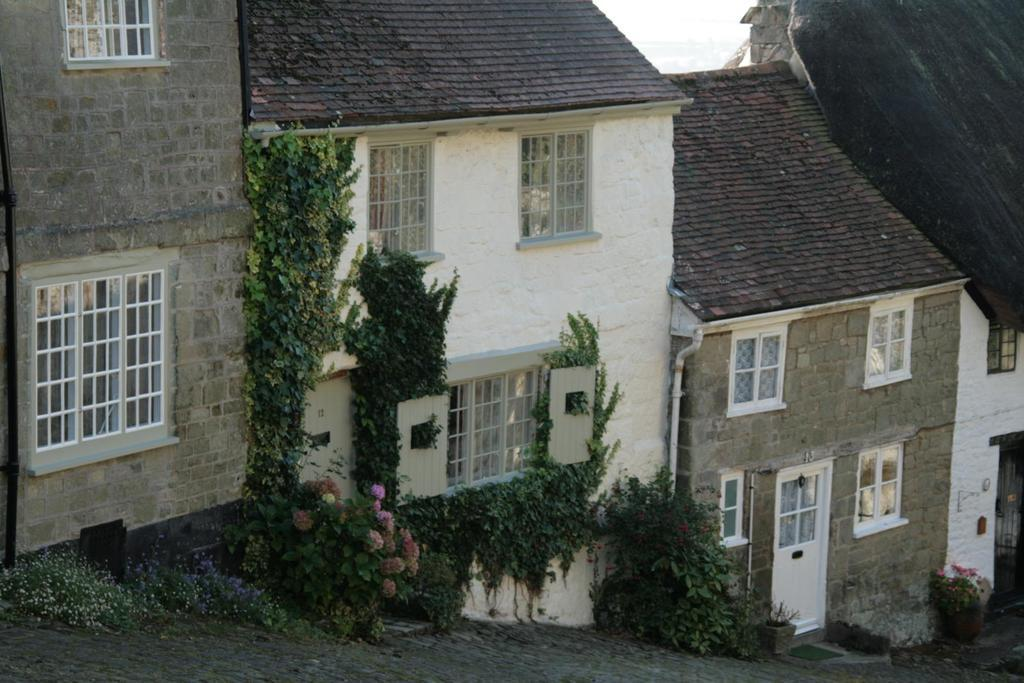What type of structures are present in the image? There are buildings in the image. What can be seen at the bottom of the image? There are plants and flowers at the bottom of the image. What feature do the buildings have? The buildings have windows. How many babies are participating in the competition in the image? There are no babies or competition present in the image. 